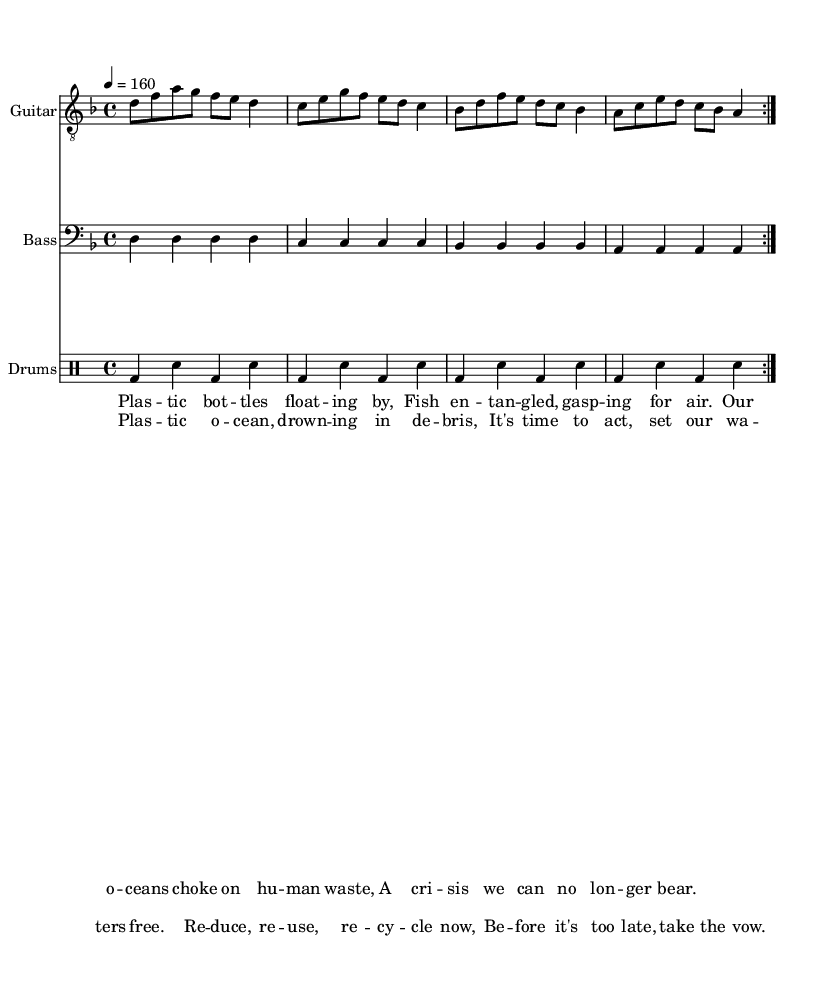What is the key signature of this music? The key signature is D minor, which includes one flat (B flat) and appears at the beginning of the music staff.
Answer: D minor What is the time signature of this piece? The time signature is 4/4, indicated at the beginning of the score, which means there are four beats in each measure.
Answer: 4/4 What is the tempo marking for the music? The tempo marking is 4 = 160, specifying the beat per minute and indicating how fast the music should be played.
Answer: 160 How many measures are repeated in the piece? The repeat symbols indicate that there are 2 measures that are repeated, which is a common practice in punk music to reinforce the themes.
Answer: 2 What is the lyrical theme of the song? The lyrics address environmental issues, particularly pollution in the oceans, which connects with the eco-punk genre focused on social and environmental activism.
Answer: Environmental issues How does the rhythm section support the punk genre? The rhythm section has a consistent and driving beat, with a pattern in the drums that provides an energetic feel typical of punk rock, unifying the group dynamic.
Answer: Energetic feel What type of instrumentation is used in this music? The instrumentation includes guitar, bass, and drums, which are the standard components of a punk band, contributing to its raw and powerful sound.
Answer: Guitar, bass, drums 